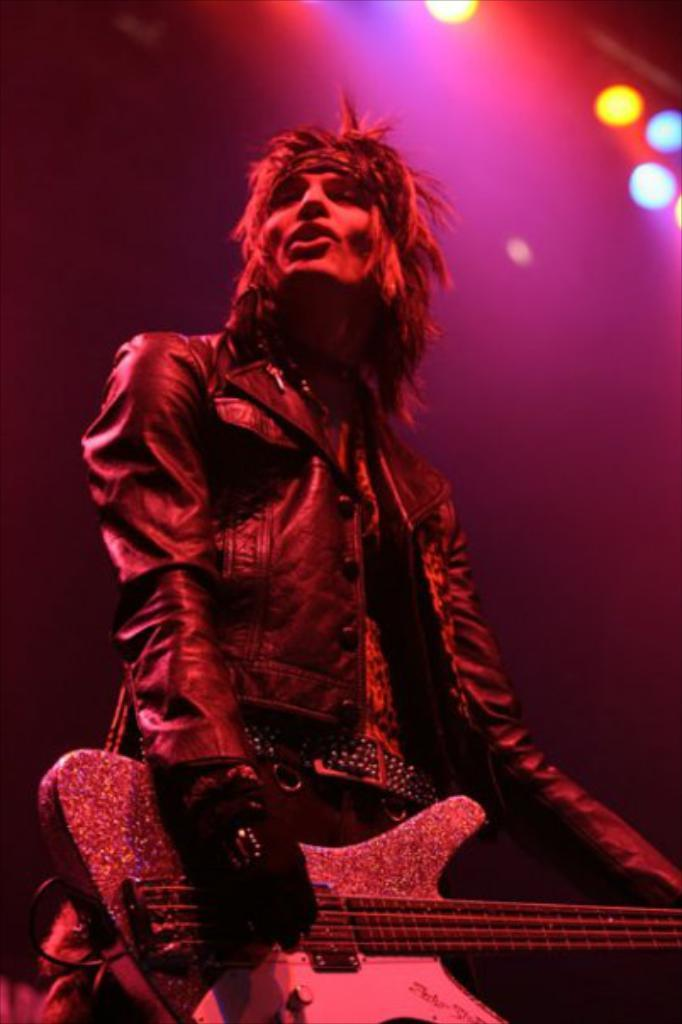Who is present in the image? There is a man in the image. What is the man doing in the image? The man is standing in the image. What object is the man holding in the image? The man is holding a guitar in the image. What type of clothing is the man wearing in the image? The man is wearing a jacket in the image. What can be seen in the background of the image? There are lights visible in the background of the image. What type of veil can be seen covering the window in the image? There is no veil or window present in the image; it features a man standing with a guitar and lights in the background. 